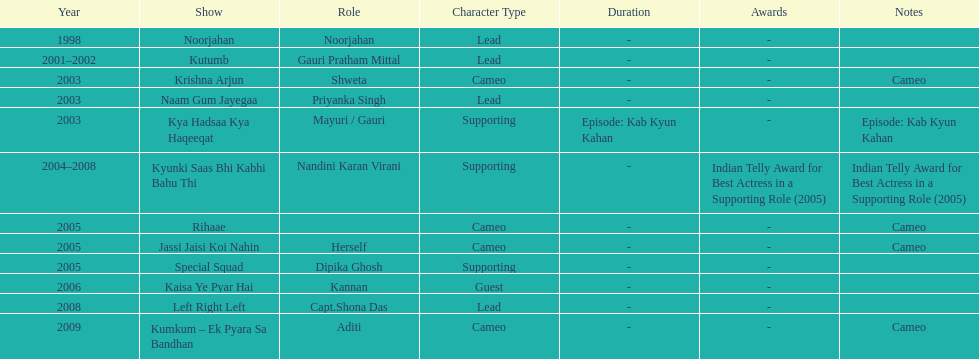What was the most years a show lasted? 4. 